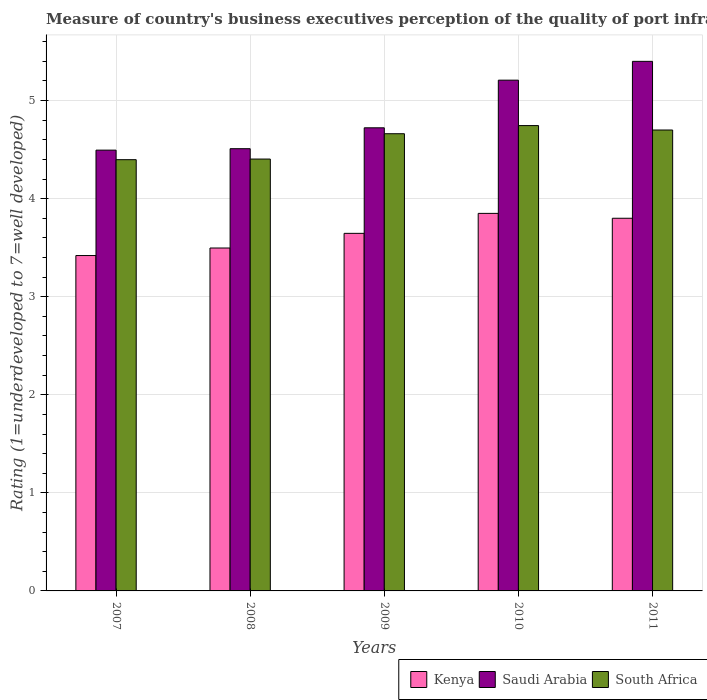How many different coloured bars are there?
Provide a short and direct response. 3. Are the number of bars on each tick of the X-axis equal?
Keep it short and to the point. Yes. How many bars are there on the 4th tick from the left?
Make the answer very short. 3. What is the label of the 3rd group of bars from the left?
Give a very brief answer. 2009. What is the ratings of the quality of port infrastructure in Saudi Arabia in 2008?
Provide a succinct answer. 4.51. Across all years, what is the maximum ratings of the quality of port infrastructure in Kenya?
Your response must be concise. 3.85. Across all years, what is the minimum ratings of the quality of port infrastructure in South Africa?
Offer a terse response. 4.4. In which year was the ratings of the quality of port infrastructure in Saudi Arabia maximum?
Make the answer very short. 2011. What is the total ratings of the quality of port infrastructure in South Africa in the graph?
Provide a short and direct response. 22.91. What is the difference between the ratings of the quality of port infrastructure in Kenya in 2007 and that in 2010?
Offer a very short reply. -0.43. What is the difference between the ratings of the quality of port infrastructure in Kenya in 2007 and the ratings of the quality of port infrastructure in South Africa in 2010?
Your answer should be compact. -1.33. What is the average ratings of the quality of port infrastructure in Saudi Arabia per year?
Your answer should be very brief. 4.87. In the year 2011, what is the difference between the ratings of the quality of port infrastructure in Saudi Arabia and ratings of the quality of port infrastructure in Kenya?
Give a very brief answer. 1.6. What is the ratio of the ratings of the quality of port infrastructure in Kenya in 2010 to that in 2011?
Your answer should be very brief. 1.01. Is the ratings of the quality of port infrastructure in Saudi Arabia in 2010 less than that in 2011?
Ensure brevity in your answer.  Yes. Is the difference between the ratings of the quality of port infrastructure in Saudi Arabia in 2010 and 2011 greater than the difference between the ratings of the quality of port infrastructure in Kenya in 2010 and 2011?
Give a very brief answer. No. What is the difference between the highest and the second highest ratings of the quality of port infrastructure in South Africa?
Offer a terse response. 0.05. What is the difference between the highest and the lowest ratings of the quality of port infrastructure in South Africa?
Provide a short and direct response. 0.35. Is the sum of the ratings of the quality of port infrastructure in South Africa in 2007 and 2011 greater than the maximum ratings of the quality of port infrastructure in Saudi Arabia across all years?
Your answer should be compact. Yes. What does the 2nd bar from the left in 2008 represents?
Offer a terse response. Saudi Arabia. What does the 2nd bar from the right in 2008 represents?
Ensure brevity in your answer.  Saudi Arabia. Is it the case that in every year, the sum of the ratings of the quality of port infrastructure in Saudi Arabia and ratings of the quality of port infrastructure in Kenya is greater than the ratings of the quality of port infrastructure in South Africa?
Make the answer very short. Yes. Are all the bars in the graph horizontal?
Make the answer very short. No. How many years are there in the graph?
Offer a very short reply. 5. Are the values on the major ticks of Y-axis written in scientific E-notation?
Make the answer very short. No. Does the graph contain any zero values?
Your answer should be compact. No. Does the graph contain grids?
Make the answer very short. Yes. Where does the legend appear in the graph?
Provide a short and direct response. Bottom right. What is the title of the graph?
Give a very brief answer. Measure of country's business executives perception of the quality of port infrastructure. Does "Iraq" appear as one of the legend labels in the graph?
Your answer should be very brief. No. What is the label or title of the Y-axis?
Make the answer very short. Rating (1=underdeveloped to 7=well developed). What is the Rating (1=underdeveloped to 7=well developed) of Kenya in 2007?
Provide a short and direct response. 3.42. What is the Rating (1=underdeveloped to 7=well developed) in Saudi Arabia in 2007?
Your answer should be compact. 4.49. What is the Rating (1=underdeveloped to 7=well developed) of South Africa in 2007?
Your answer should be compact. 4.4. What is the Rating (1=underdeveloped to 7=well developed) in Kenya in 2008?
Your answer should be compact. 3.5. What is the Rating (1=underdeveloped to 7=well developed) in Saudi Arabia in 2008?
Your answer should be very brief. 4.51. What is the Rating (1=underdeveloped to 7=well developed) in South Africa in 2008?
Offer a very short reply. 4.4. What is the Rating (1=underdeveloped to 7=well developed) of Kenya in 2009?
Offer a very short reply. 3.65. What is the Rating (1=underdeveloped to 7=well developed) of Saudi Arabia in 2009?
Offer a very short reply. 4.72. What is the Rating (1=underdeveloped to 7=well developed) of South Africa in 2009?
Provide a succinct answer. 4.66. What is the Rating (1=underdeveloped to 7=well developed) in Kenya in 2010?
Make the answer very short. 3.85. What is the Rating (1=underdeveloped to 7=well developed) in Saudi Arabia in 2010?
Give a very brief answer. 5.21. What is the Rating (1=underdeveloped to 7=well developed) in South Africa in 2010?
Your answer should be compact. 4.75. What is the Rating (1=underdeveloped to 7=well developed) in Kenya in 2011?
Provide a succinct answer. 3.8. What is the Rating (1=underdeveloped to 7=well developed) of Saudi Arabia in 2011?
Your response must be concise. 5.4. What is the Rating (1=underdeveloped to 7=well developed) of South Africa in 2011?
Give a very brief answer. 4.7. Across all years, what is the maximum Rating (1=underdeveloped to 7=well developed) in Kenya?
Your answer should be compact. 3.85. Across all years, what is the maximum Rating (1=underdeveloped to 7=well developed) of Saudi Arabia?
Give a very brief answer. 5.4. Across all years, what is the maximum Rating (1=underdeveloped to 7=well developed) in South Africa?
Your answer should be very brief. 4.75. Across all years, what is the minimum Rating (1=underdeveloped to 7=well developed) of Kenya?
Make the answer very short. 3.42. Across all years, what is the minimum Rating (1=underdeveloped to 7=well developed) in Saudi Arabia?
Your answer should be compact. 4.49. Across all years, what is the minimum Rating (1=underdeveloped to 7=well developed) in South Africa?
Give a very brief answer. 4.4. What is the total Rating (1=underdeveloped to 7=well developed) of Kenya in the graph?
Provide a short and direct response. 18.21. What is the total Rating (1=underdeveloped to 7=well developed) in Saudi Arabia in the graph?
Your answer should be very brief. 24.33. What is the total Rating (1=underdeveloped to 7=well developed) in South Africa in the graph?
Offer a very short reply. 22.91. What is the difference between the Rating (1=underdeveloped to 7=well developed) in Kenya in 2007 and that in 2008?
Offer a terse response. -0.08. What is the difference between the Rating (1=underdeveloped to 7=well developed) in Saudi Arabia in 2007 and that in 2008?
Offer a terse response. -0.01. What is the difference between the Rating (1=underdeveloped to 7=well developed) in South Africa in 2007 and that in 2008?
Offer a very short reply. -0.01. What is the difference between the Rating (1=underdeveloped to 7=well developed) of Kenya in 2007 and that in 2009?
Make the answer very short. -0.23. What is the difference between the Rating (1=underdeveloped to 7=well developed) of Saudi Arabia in 2007 and that in 2009?
Offer a terse response. -0.23. What is the difference between the Rating (1=underdeveloped to 7=well developed) in South Africa in 2007 and that in 2009?
Provide a short and direct response. -0.26. What is the difference between the Rating (1=underdeveloped to 7=well developed) of Kenya in 2007 and that in 2010?
Provide a short and direct response. -0.43. What is the difference between the Rating (1=underdeveloped to 7=well developed) in Saudi Arabia in 2007 and that in 2010?
Provide a short and direct response. -0.71. What is the difference between the Rating (1=underdeveloped to 7=well developed) of South Africa in 2007 and that in 2010?
Give a very brief answer. -0.35. What is the difference between the Rating (1=underdeveloped to 7=well developed) in Kenya in 2007 and that in 2011?
Offer a terse response. -0.38. What is the difference between the Rating (1=underdeveloped to 7=well developed) in Saudi Arabia in 2007 and that in 2011?
Offer a very short reply. -0.91. What is the difference between the Rating (1=underdeveloped to 7=well developed) in South Africa in 2007 and that in 2011?
Offer a very short reply. -0.3. What is the difference between the Rating (1=underdeveloped to 7=well developed) of Kenya in 2008 and that in 2009?
Give a very brief answer. -0.15. What is the difference between the Rating (1=underdeveloped to 7=well developed) in Saudi Arabia in 2008 and that in 2009?
Your answer should be compact. -0.21. What is the difference between the Rating (1=underdeveloped to 7=well developed) of South Africa in 2008 and that in 2009?
Provide a succinct answer. -0.26. What is the difference between the Rating (1=underdeveloped to 7=well developed) of Kenya in 2008 and that in 2010?
Your response must be concise. -0.35. What is the difference between the Rating (1=underdeveloped to 7=well developed) in Saudi Arabia in 2008 and that in 2010?
Your answer should be very brief. -0.7. What is the difference between the Rating (1=underdeveloped to 7=well developed) of South Africa in 2008 and that in 2010?
Give a very brief answer. -0.34. What is the difference between the Rating (1=underdeveloped to 7=well developed) of Kenya in 2008 and that in 2011?
Provide a succinct answer. -0.3. What is the difference between the Rating (1=underdeveloped to 7=well developed) in Saudi Arabia in 2008 and that in 2011?
Give a very brief answer. -0.89. What is the difference between the Rating (1=underdeveloped to 7=well developed) in South Africa in 2008 and that in 2011?
Provide a succinct answer. -0.3. What is the difference between the Rating (1=underdeveloped to 7=well developed) in Kenya in 2009 and that in 2010?
Ensure brevity in your answer.  -0.2. What is the difference between the Rating (1=underdeveloped to 7=well developed) in Saudi Arabia in 2009 and that in 2010?
Provide a short and direct response. -0.49. What is the difference between the Rating (1=underdeveloped to 7=well developed) in South Africa in 2009 and that in 2010?
Offer a terse response. -0.08. What is the difference between the Rating (1=underdeveloped to 7=well developed) of Kenya in 2009 and that in 2011?
Offer a very short reply. -0.15. What is the difference between the Rating (1=underdeveloped to 7=well developed) in Saudi Arabia in 2009 and that in 2011?
Your answer should be compact. -0.68. What is the difference between the Rating (1=underdeveloped to 7=well developed) in South Africa in 2009 and that in 2011?
Provide a succinct answer. -0.04. What is the difference between the Rating (1=underdeveloped to 7=well developed) in Kenya in 2010 and that in 2011?
Ensure brevity in your answer.  0.05. What is the difference between the Rating (1=underdeveloped to 7=well developed) in Saudi Arabia in 2010 and that in 2011?
Offer a very short reply. -0.19. What is the difference between the Rating (1=underdeveloped to 7=well developed) in South Africa in 2010 and that in 2011?
Offer a terse response. 0.05. What is the difference between the Rating (1=underdeveloped to 7=well developed) of Kenya in 2007 and the Rating (1=underdeveloped to 7=well developed) of Saudi Arabia in 2008?
Offer a very short reply. -1.09. What is the difference between the Rating (1=underdeveloped to 7=well developed) in Kenya in 2007 and the Rating (1=underdeveloped to 7=well developed) in South Africa in 2008?
Your answer should be very brief. -0.98. What is the difference between the Rating (1=underdeveloped to 7=well developed) of Saudi Arabia in 2007 and the Rating (1=underdeveloped to 7=well developed) of South Africa in 2008?
Your response must be concise. 0.09. What is the difference between the Rating (1=underdeveloped to 7=well developed) in Kenya in 2007 and the Rating (1=underdeveloped to 7=well developed) in Saudi Arabia in 2009?
Your response must be concise. -1.3. What is the difference between the Rating (1=underdeveloped to 7=well developed) in Kenya in 2007 and the Rating (1=underdeveloped to 7=well developed) in South Africa in 2009?
Your response must be concise. -1.24. What is the difference between the Rating (1=underdeveloped to 7=well developed) of Saudi Arabia in 2007 and the Rating (1=underdeveloped to 7=well developed) of South Africa in 2009?
Ensure brevity in your answer.  -0.17. What is the difference between the Rating (1=underdeveloped to 7=well developed) in Kenya in 2007 and the Rating (1=underdeveloped to 7=well developed) in Saudi Arabia in 2010?
Make the answer very short. -1.79. What is the difference between the Rating (1=underdeveloped to 7=well developed) in Kenya in 2007 and the Rating (1=underdeveloped to 7=well developed) in South Africa in 2010?
Offer a very short reply. -1.33. What is the difference between the Rating (1=underdeveloped to 7=well developed) of Saudi Arabia in 2007 and the Rating (1=underdeveloped to 7=well developed) of South Africa in 2010?
Offer a very short reply. -0.25. What is the difference between the Rating (1=underdeveloped to 7=well developed) in Kenya in 2007 and the Rating (1=underdeveloped to 7=well developed) in Saudi Arabia in 2011?
Provide a succinct answer. -1.98. What is the difference between the Rating (1=underdeveloped to 7=well developed) of Kenya in 2007 and the Rating (1=underdeveloped to 7=well developed) of South Africa in 2011?
Provide a short and direct response. -1.28. What is the difference between the Rating (1=underdeveloped to 7=well developed) in Saudi Arabia in 2007 and the Rating (1=underdeveloped to 7=well developed) in South Africa in 2011?
Your answer should be very brief. -0.21. What is the difference between the Rating (1=underdeveloped to 7=well developed) of Kenya in 2008 and the Rating (1=underdeveloped to 7=well developed) of Saudi Arabia in 2009?
Ensure brevity in your answer.  -1.23. What is the difference between the Rating (1=underdeveloped to 7=well developed) of Kenya in 2008 and the Rating (1=underdeveloped to 7=well developed) of South Africa in 2009?
Your answer should be compact. -1.17. What is the difference between the Rating (1=underdeveloped to 7=well developed) in Saudi Arabia in 2008 and the Rating (1=underdeveloped to 7=well developed) in South Africa in 2009?
Offer a very short reply. -0.15. What is the difference between the Rating (1=underdeveloped to 7=well developed) in Kenya in 2008 and the Rating (1=underdeveloped to 7=well developed) in Saudi Arabia in 2010?
Ensure brevity in your answer.  -1.71. What is the difference between the Rating (1=underdeveloped to 7=well developed) in Kenya in 2008 and the Rating (1=underdeveloped to 7=well developed) in South Africa in 2010?
Your answer should be very brief. -1.25. What is the difference between the Rating (1=underdeveloped to 7=well developed) of Saudi Arabia in 2008 and the Rating (1=underdeveloped to 7=well developed) of South Africa in 2010?
Give a very brief answer. -0.24. What is the difference between the Rating (1=underdeveloped to 7=well developed) in Kenya in 2008 and the Rating (1=underdeveloped to 7=well developed) in Saudi Arabia in 2011?
Provide a succinct answer. -1.9. What is the difference between the Rating (1=underdeveloped to 7=well developed) of Kenya in 2008 and the Rating (1=underdeveloped to 7=well developed) of South Africa in 2011?
Your response must be concise. -1.2. What is the difference between the Rating (1=underdeveloped to 7=well developed) of Saudi Arabia in 2008 and the Rating (1=underdeveloped to 7=well developed) of South Africa in 2011?
Provide a short and direct response. -0.19. What is the difference between the Rating (1=underdeveloped to 7=well developed) of Kenya in 2009 and the Rating (1=underdeveloped to 7=well developed) of Saudi Arabia in 2010?
Keep it short and to the point. -1.56. What is the difference between the Rating (1=underdeveloped to 7=well developed) of Kenya in 2009 and the Rating (1=underdeveloped to 7=well developed) of South Africa in 2010?
Keep it short and to the point. -1.1. What is the difference between the Rating (1=underdeveloped to 7=well developed) in Saudi Arabia in 2009 and the Rating (1=underdeveloped to 7=well developed) in South Africa in 2010?
Give a very brief answer. -0.02. What is the difference between the Rating (1=underdeveloped to 7=well developed) of Kenya in 2009 and the Rating (1=underdeveloped to 7=well developed) of Saudi Arabia in 2011?
Offer a very short reply. -1.75. What is the difference between the Rating (1=underdeveloped to 7=well developed) in Kenya in 2009 and the Rating (1=underdeveloped to 7=well developed) in South Africa in 2011?
Give a very brief answer. -1.05. What is the difference between the Rating (1=underdeveloped to 7=well developed) in Saudi Arabia in 2009 and the Rating (1=underdeveloped to 7=well developed) in South Africa in 2011?
Keep it short and to the point. 0.02. What is the difference between the Rating (1=underdeveloped to 7=well developed) of Kenya in 2010 and the Rating (1=underdeveloped to 7=well developed) of Saudi Arabia in 2011?
Keep it short and to the point. -1.55. What is the difference between the Rating (1=underdeveloped to 7=well developed) of Kenya in 2010 and the Rating (1=underdeveloped to 7=well developed) of South Africa in 2011?
Provide a succinct answer. -0.85. What is the difference between the Rating (1=underdeveloped to 7=well developed) in Saudi Arabia in 2010 and the Rating (1=underdeveloped to 7=well developed) in South Africa in 2011?
Your response must be concise. 0.51. What is the average Rating (1=underdeveloped to 7=well developed) in Kenya per year?
Your answer should be compact. 3.64. What is the average Rating (1=underdeveloped to 7=well developed) of Saudi Arabia per year?
Your answer should be compact. 4.87. What is the average Rating (1=underdeveloped to 7=well developed) of South Africa per year?
Provide a short and direct response. 4.58. In the year 2007, what is the difference between the Rating (1=underdeveloped to 7=well developed) of Kenya and Rating (1=underdeveloped to 7=well developed) of Saudi Arabia?
Provide a succinct answer. -1.07. In the year 2007, what is the difference between the Rating (1=underdeveloped to 7=well developed) of Kenya and Rating (1=underdeveloped to 7=well developed) of South Africa?
Provide a short and direct response. -0.98. In the year 2007, what is the difference between the Rating (1=underdeveloped to 7=well developed) in Saudi Arabia and Rating (1=underdeveloped to 7=well developed) in South Africa?
Make the answer very short. 0.1. In the year 2008, what is the difference between the Rating (1=underdeveloped to 7=well developed) of Kenya and Rating (1=underdeveloped to 7=well developed) of Saudi Arabia?
Ensure brevity in your answer.  -1.01. In the year 2008, what is the difference between the Rating (1=underdeveloped to 7=well developed) of Kenya and Rating (1=underdeveloped to 7=well developed) of South Africa?
Ensure brevity in your answer.  -0.91. In the year 2008, what is the difference between the Rating (1=underdeveloped to 7=well developed) of Saudi Arabia and Rating (1=underdeveloped to 7=well developed) of South Africa?
Keep it short and to the point. 0.11. In the year 2009, what is the difference between the Rating (1=underdeveloped to 7=well developed) in Kenya and Rating (1=underdeveloped to 7=well developed) in Saudi Arabia?
Your answer should be very brief. -1.08. In the year 2009, what is the difference between the Rating (1=underdeveloped to 7=well developed) of Kenya and Rating (1=underdeveloped to 7=well developed) of South Africa?
Your response must be concise. -1.02. In the year 2009, what is the difference between the Rating (1=underdeveloped to 7=well developed) in Saudi Arabia and Rating (1=underdeveloped to 7=well developed) in South Africa?
Offer a very short reply. 0.06. In the year 2010, what is the difference between the Rating (1=underdeveloped to 7=well developed) in Kenya and Rating (1=underdeveloped to 7=well developed) in Saudi Arabia?
Offer a very short reply. -1.36. In the year 2010, what is the difference between the Rating (1=underdeveloped to 7=well developed) in Kenya and Rating (1=underdeveloped to 7=well developed) in South Africa?
Make the answer very short. -0.9. In the year 2010, what is the difference between the Rating (1=underdeveloped to 7=well developed) in Saudi Arabia and Rating (1=underdeveloped to 7=well developed) in South Africa?
Your answer should be compact. 0.46. In the year 2011, what is the difference between the Rating (1=underdeveloped to 7=well developed) in Kenya and Rating (1=underdeveloped to 7=well developed) in Saudi Arabia?
Offer a terse response. -1.6. In the year 2011, what is the difference between the Rating (1=underdeveloped to 7=well developed) of Kenya and Rating (1=underdeveloped to 7=well developed) of South Africa?
Offer a terse response. -0.9. In the year 2011, what is the difference between the Rating (1=underdeveloped to 7=well developed) of Saudi Arabia and Rating (1=underdeveloped to 7=well developed) of South Africa?
Your response must be concise. 0.7. What is the ratio of the Rating (1=underdeveloped to 7=well developed) in Kenya in 2007 to that in 2008?
Offer a terse response. 0.98. What is the ratio of the Rating (1=underdeveloped to 7=well developed) of Saudi Arabia in 2007 to that in 2008?
Keep it short and to the point. 1. What is the ratio of the Rating (1=underdeveloped to 7=well developed) of South Africa in 2007 to that in 2008?
Provide a succinct answer. 1. What is the ratio of the Rating (1=underdeveloped to 7=well developed) of Kenya in 2007 to that in 2009?
Give a very brief answer. 0.94. What is the ratio of the Rating (1=underdeveloped to 7=well developed) in Saudi Arabia in 2007 to that in 2009?
Offer a very short reply. 0.95. What is the ratio of the Rating (1=underdeveloped to 7=well developed) of South Africa in 2007 to that in 2009?
Offer a terse response. 0.94. What is the ratio of the Rating (1=underdeveloped to 7=well developed) of Kenya in 2007 to that in 2010?
Offer a terse response. 0.89. What is the ratio of the Rating (1=underdeveloped to 7=well developed) in Saudi Arabia in 2007 to that in 2010?
Make the answer very short. 0.86. What is the ratio of the Rating (1=underdeveloped to 7=well developed) in South Africa in 2007 to that in 2010?
Your answer should be compact. 0.93. What is the ratio of the Rating (1=underdeveloped to 7=well developed) in Kenya in 2007 to that in 2011?
Provide a succinct answer. 0.9. What is the ratio of the Rating (1=underdeveloped to 7=well developed) in Saudi Arabia in 2007 to that in 2011?
Your answer should be very brief. 0.83. What is the ratio of the Rating (1=underdeveloped to 7=well developed) of South Africa in 2007 to that in 2011?
Your answer should be very brief. 0.94. What is the ratio of the Rating (1=underdeveloped to 7=well developed) of Saudi Arabia in 2008 to that in 2009?
Provide a succinct answer. 0.95. What is the ratio of the Rating (1=underdeveloped to 7=well developed) in South Africa in 2008 to that in 2009?
Offer a very short reply. 0.94. What is the ratio of the Rating (1=underdeveloped to 7=well developed) of Kenya in 2008 to that in 2010?
Your response must be concise. 0.91. What is the ratio of the Rating (1=underdeveloped to 7=well developed) in Saudi Arabia in 2008 to that in 2010?
Your answer should be very brief. 0.87. What is the ratio of the Rating (1=underdeveloped to 7=well developed) in South Africa in 2008 to that in 2010?
Your answer should be very brief. 0.93. What is the ratio of the Rating (1=underdeveloped to 7=well developed) of Kenya in 2008 to that in 2011?
Make the answer very short. 0.92. What is the ratio of the Rating (1=underdeveloped to 7=well developed) in Saudi Arabia in 2008 to that in 2011?
Ensure brevity in your answer.  0.84. What is the ratio of the Rating (1=underdeveloped to 7=well developed) of South Africa in 2008 to that in 2011?
Ensure brevity in your answer.  0.94. What is the ratio of the Rating (1=underdeveloped to 7=well developed) in Kenya in 2009 to that in 2010?
Offer a very short reply. 0.95. What is the ratio of the Rating (1=underdeveloped to 7=well developed) in Saudi Arabia in 2009 to that in 2010?
Provide a succinct answer. 0.91. What is the ratio of the Rating (1=underdeveloped to 7=well developed) of South Africa in 2009 to that in 2010?
Offer a terse response. 0.98. What is the ratio of the Rating (1=underdeveloped to 7=well developed) in Kenya in 2009 to that in 2011?
Provide a succinct answer. 0.96. What is the ratio of the Rating (1=underdeveloped to 7=well developed) in Saudi Arabia in 2009 to that in 2011?
Your response must be concise. 0.87. What is the ratio of the Rating (1=underdeveloped to 7=well developed) in Kenya in 2010 to that in 2011?
Ensure brevity in your answer.  1.01. What is the ratio of the Rating (1=underdeveloped to 7=well developed) in Saudi Arabia in 2010 to that in 2011?
Give a very brief answer. 0.96. What is the ratio of the Rating (1=underdeveloped to 7=well developed) in South Africa in 2010 to that in 2011?
Provide a succinct answer. 1.01. What is the difference between the highest and the second highest Rating (1=underdeveloped to 7=well developed) of Kenya?
Ensure brevity in your answer.  0.05. What is the difference between the highest and the second highest Rating (1=underdeveloped to 7=well developed) in Saudi Arabia?
Your answer should be very brief. 0.19. What is the difference between the highest and the second highest Rating (1=underdeveloped to 7=well developed) in South Africa?
Your answer should be compact. 0.05. What is the difference between the highest and the lowest Rating (1=underdeveloped to 7=well developed) of Kenya?
Make the answer very short. 0.43. What is the difference between the highest and the lowest Rating (1=underdeveloped to 7=well developed) in Saudi Arabia?
Ensure brevity in your answer.  0.91. What is the difference between the highest and the lowest Rating (1=underdeveloped to 7=well developed) in South Africa?
Make the answer very short. 0.35. 